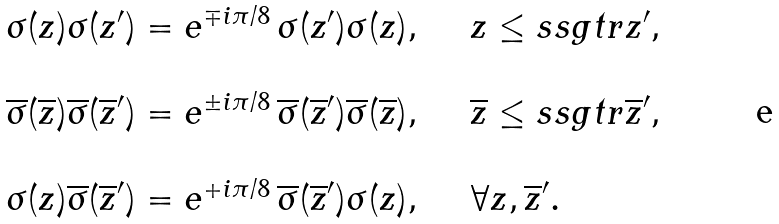<formula> <loc_0><loc_0><loc_500><loc_500>\begin{array} { l l } \sigma ( z ) \sigma ( z ^ { \prime } ) = e ^ { \mp i \pi / 8 } \, \sigma ( z ^ { \prime } ) \sigma ( z ) , & \quad z \leq s s g t r z ^ { \prime } , \\ \\ \overline { \sigma } ( \overline { z } ) \overline { \sigma } ( \overline { z } ^ { \prime } ) = e ^ { \pm i \pi / 8 } \, \overline { \sigma } ( \overline { z } ^ { \prime } ) \overline { \sigma } ( \overline { z } ) , & \quad \overline { z } \leq s s g t r \overline { z } ^ { \prime } , \\ \\ \sigma ( z ) \overline { \sigma } ( \overline { z } ^ { \prime } ) = e ^ { + i \pi / 8 } \, \overline { \sigma } ( \overline { z } ^ { \prime } ) \sigma ( z ) , & \quad \forall z , \overline { z } ^ { \prime } . \end{array}</formula> 